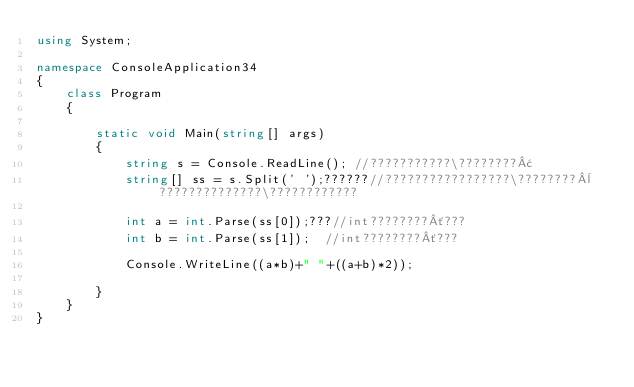<code> <loc_0><loc_0><loc_500><loc_500><_C#_>using System;

namespace ConsoleApplication34
{
    class Program
    {
       
        static void Main(string[] args)
        {
            string s = Console.ReadLine(); //???????????\????????¢
            string[] ss = s.Split(' ');??????//?????????????????\????????¨??????????????\????????????

            int a = int.Parse(ss[0]);???//int????????´???
            int b = int.Parse(ss[1]);  //int????????´???
            
            Console.WriteLine((a*b)+" "+((a+b)*2));

        }
    }
}</code> 